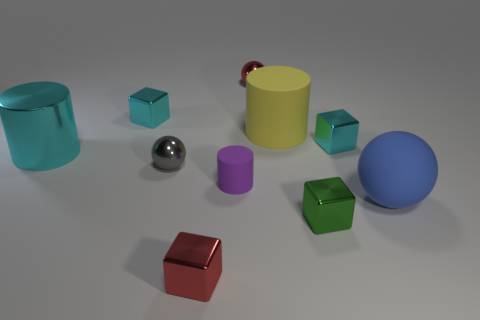Subtract all cylinders. How many objects are left? 7 Subtract all gray spheres. How many spheres are left? 2 Subtract 1 cylinders. How many cylinders are left? 2 Subtract all red spheres. Subtract all brown cylinders. How many spheres are left? 2 Subtract all green cylinders. How many red blocks are left? 1 Subtract all blue spheres. Subtract all tiny cyan things. How many objects are left? 7 Add 8 blue rubber balls. How many blue rubber balls are left? 9 Add 6 tiny yellow matte things. How many tiny yellow matte things exist? 6 Subtract all large matte cylinders. How many cylinders are left? 2 Subtract 0 gray cylinders. How many objects are left? 10 